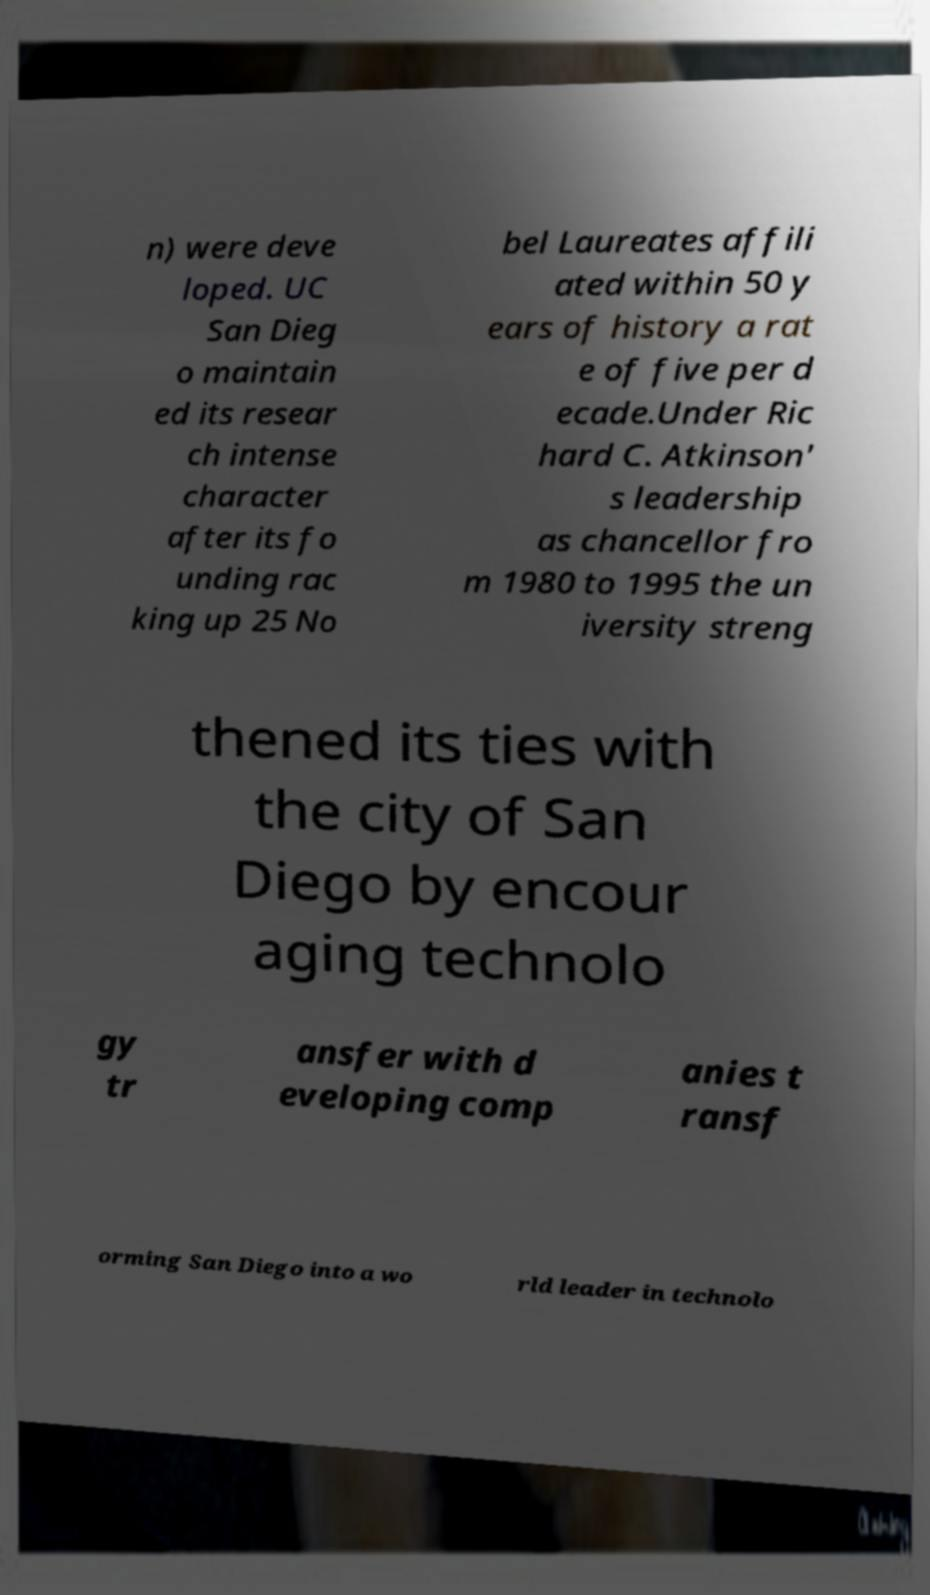Could you extract and type out the text from this image? n) were deve loped. UC San Dieg o maintain ed its resear ch intense character after its fo unding rac king up 25 No bel Laureates affili ated within 50 y ears of history a rat e of five per d ecade.Under Ric hard C. Atkinson' s leadership as chancellor fro m 1980 to 1995 the un iversity streng thened its ties with the city of San Diego by encour aging technolo gy tr ansfer with d eveloping comp anies t ransf orming San Diego into a wo rld leader in technolo 